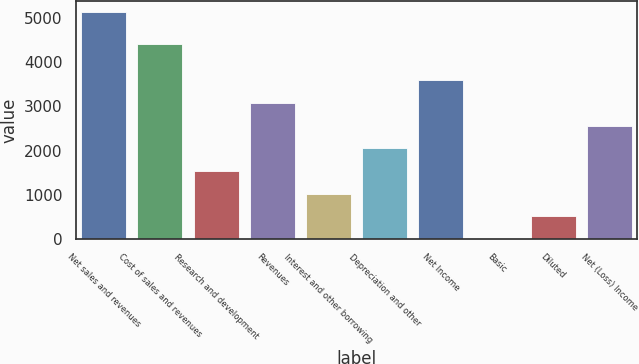<chart> <loc_0><loc_0><loc_500><loc_500><bar_chart><fcel>Net sales and revenues<fcel>Cost of sales and revenues<fcel>Research and development<fcel>Revenues<fcel>Interest and other borrowing<fcel>Depreciation and other<fcel>Net Income<fcel>Basic<fcel>Diluted<fcel>Net (Loss) Income<nl><fcel>5122.4<fcel>4409.5<fcel>1537.88<fcel>3074.09<fcel>1025.81<fcel>2049.95<fcel>3586.16<fcel>1.67<fcel>513.74<fcel>2562.02<nl></chart> 